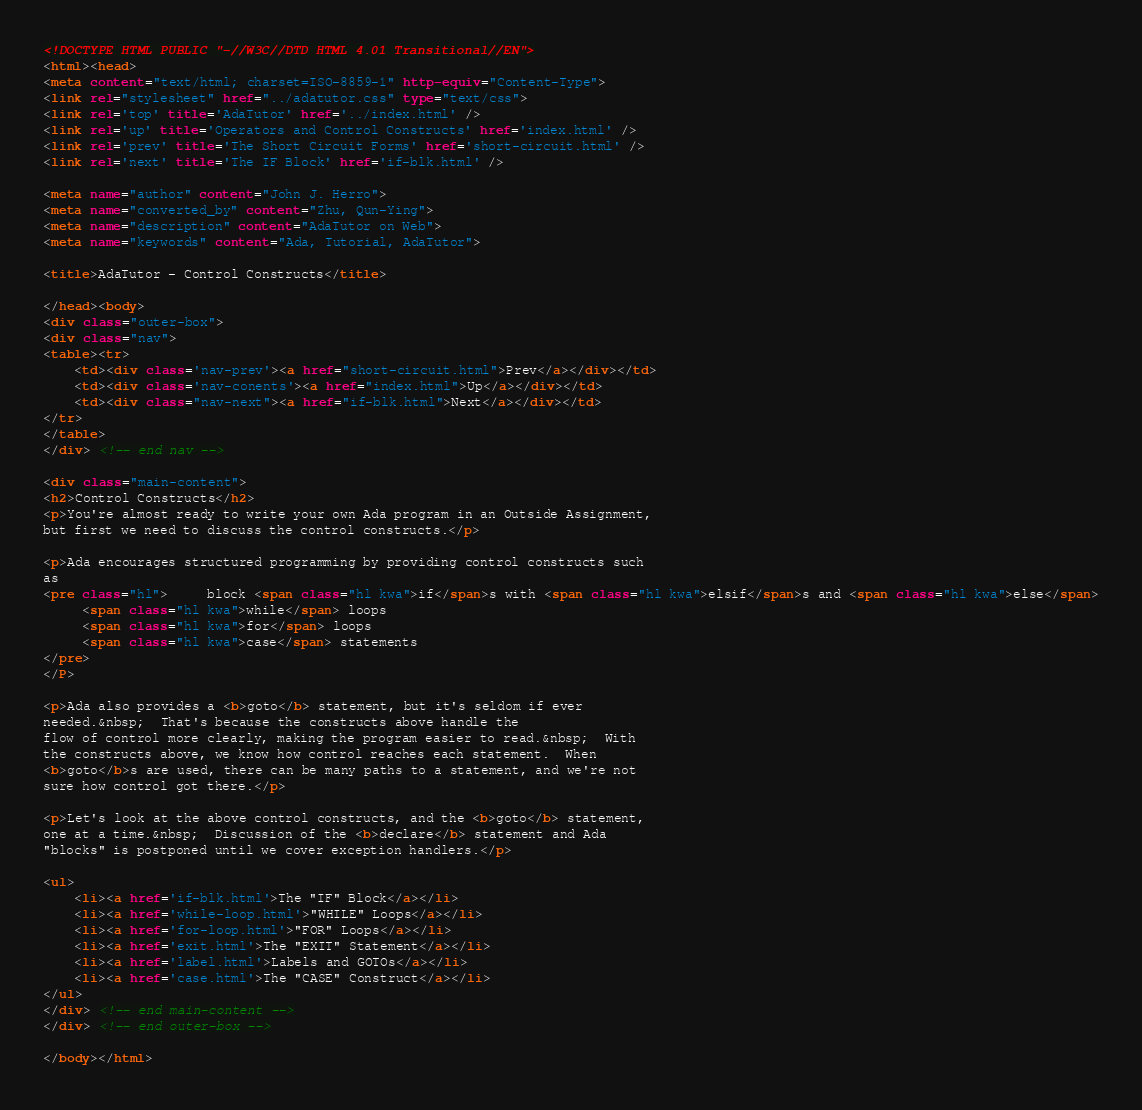<code> <loc_0><loc_0><loc_500><loc_500><_HTML_><!DOCTYPE HTML PUBLIC "-//W3C//DTD HTML 4.01 Transitional//EN">
<html><head>
<meta content="text/html; charset=ISO-8859-1" http-equiv="Content-Type">
<link rel="stylesheet" href="../adatutor.css" type="text/css">
<link rel='top' title='AdaTutor' href='../index.html' />
<link rel='up' title='Operators and Control Constructs' href='index.html' />
<link rel='prev' title='The Short Circuit Forms' href='short-circuit.html' />
<link rel='next' title='The IF Block' href='if-blk.html' />

<meta name="author" content="John J. Herro">
<meta name="converted_by" content="Zhu, Qun-Ying">
<meta name="description" content="AdaTutor on Web">
<meta name="keywords" content="Ada, Tutorial, AdaTutor">

<title>AdaTutor - Control Constructs</title>

</head><body>
<div class="outer-box">
<div class="nav">
<table><tr>
	<td><div class='nav-prev'><a href="short-circuit.html">Prev</a></div></td>
	<td><div class='nav-conents'><a href="index.html">Up</a></div></td>
	<td><div class="nav-next"><a href="if-blk.html">Next</a></div></td>
</tr>
</table>
</div> <!-- end nav -->

<div class="main-content">
<h2>Control Constructs</h2>
<p>You're almost ready to write your own Ada program in an Outside Assignment,
but first we need to discuss the control constructs.</p>

<p>Ada encourages structured programming by providing control constructs such
as
<pre class="hl">     block <span class="hl kwa">if</span>s with <span class="hl kwa">elsif</span>s and <span class="hl kwa">else</span>
     <span class="hl kwa">while</span> loops
     <span class="hl kwa">for</span> loops
     <span class="hl kwa">case</span> statements
</pre>
</P>

<p>Ada also provides a <b>goto</b> statement, but it's seldom if ever
needed.&nbsp;  That's because the constructs above handle the
flow of control more clearly, making the program easier to read.&nbsp;  With
the constructs above, we know how control reaches each statement.  When
<b>goto</b>s are used, there can be many paths to a statement, and we're not
sure how control got there.</p>

<p>Let's look at the above control constructs, and the <b>goto</b> statement,
one at a time.&nbsp;  Discussion of the <b>declare</b> statement and Ada
"blocks" is postponed until we cover exception handlers.</p>

<ul>
    <li><a href='if-blk.html'>The "IF" Block</a></li>
    <li><a href='while-loop.html'>"WHILE" Loops</a></li>
    <li><a href='for-loop.html'>"FOR" Loops</a></li>
    <li><a href='exit.html'>The "EXIT" Statement</a></li>
    <li><a href='label.html'>Labels and GOTOs</a></li>
    <li><a href='case.html'>The "CASE" Construct</a></li>
</ul>
</div> <!-- end main-content -->
</div> <!-- end outer-box -->

</body></html>
</code> 